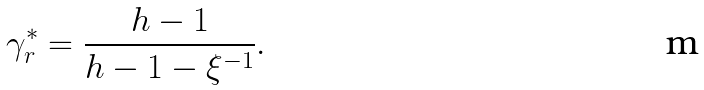<formula> <loc_0><loc_0><loc_500><loc_500>\gamma _ { r } ^ { \ast } = \frac { h - 1 } { h - 1 - \xi ^ { - 1 } } .</formula> 